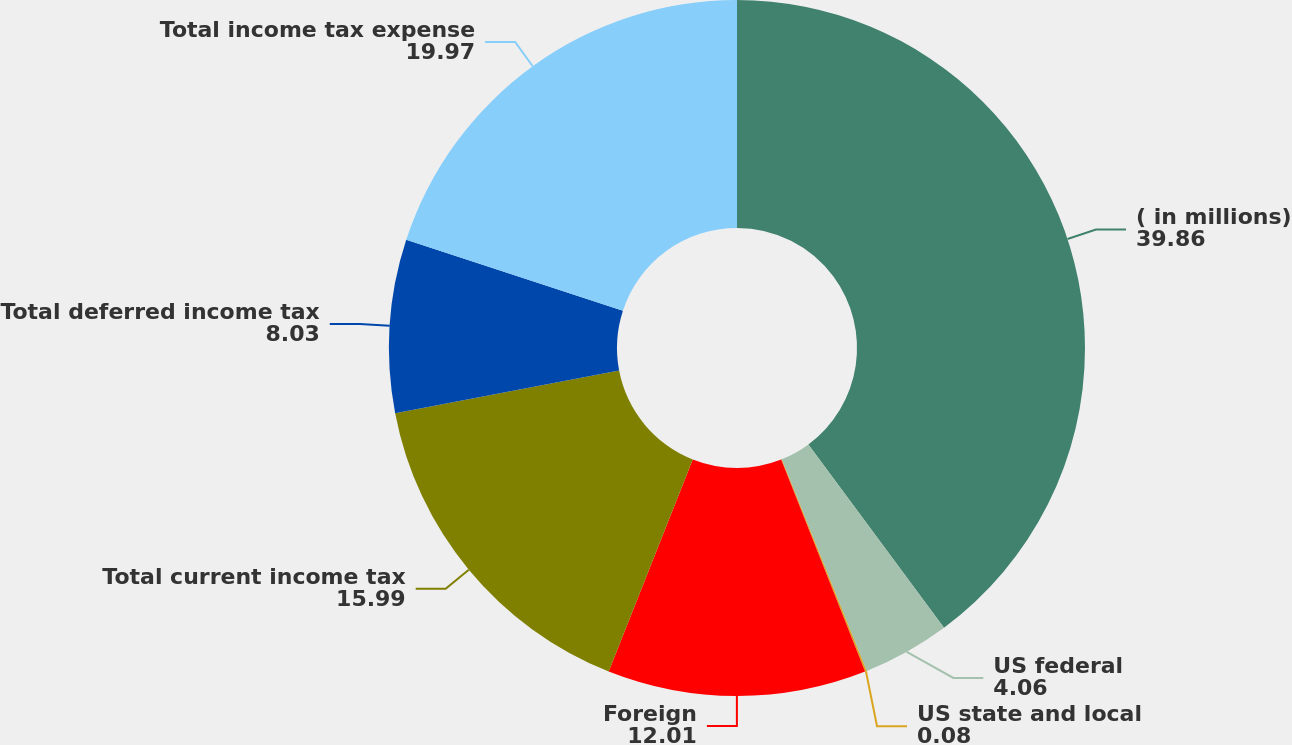Convert chart. <chart><loc_0><loc_0><loc_500><loc_500><pie_chart><fcel>( in millions)<fcel>US federal<fcel>US state and local<fcel>Foreign<fcel>Total current income tax<fcel>Total deferred income tax<fcel>Total income tax expense<nl><fcel>39.86%<fcel>4.06%<fcel>0.08%<fcel>12.01%<fcel>15.99%<fcel>8.03%<fcel>19.97%<nl></chart> 